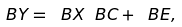Convert formula to latex. <formula><loc_0><loc_0><loc_500><loc_500>\ B { Y } = \ B { X } \ B { C } + \ B { E } ,</formula> 